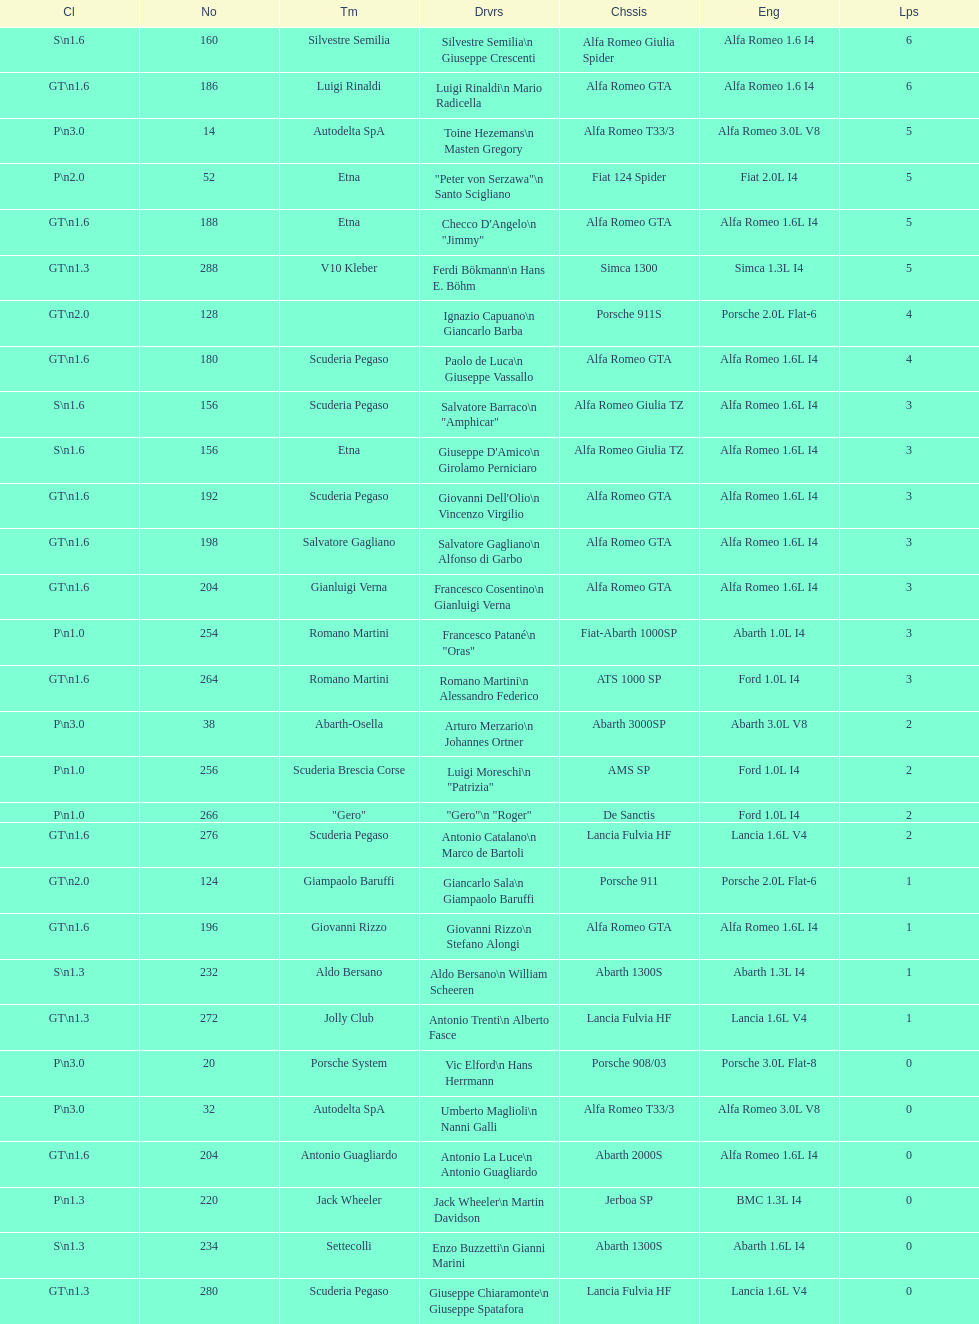Name the only american who did not finish the race. Masten Gregory. 